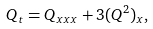<formula> <loc_0><loc_0><loc_500><loc_500>Q _ { t } = Q _ { x x x } + 3 ( Q ^ { 2 } ) _ { x } ,</formula> 